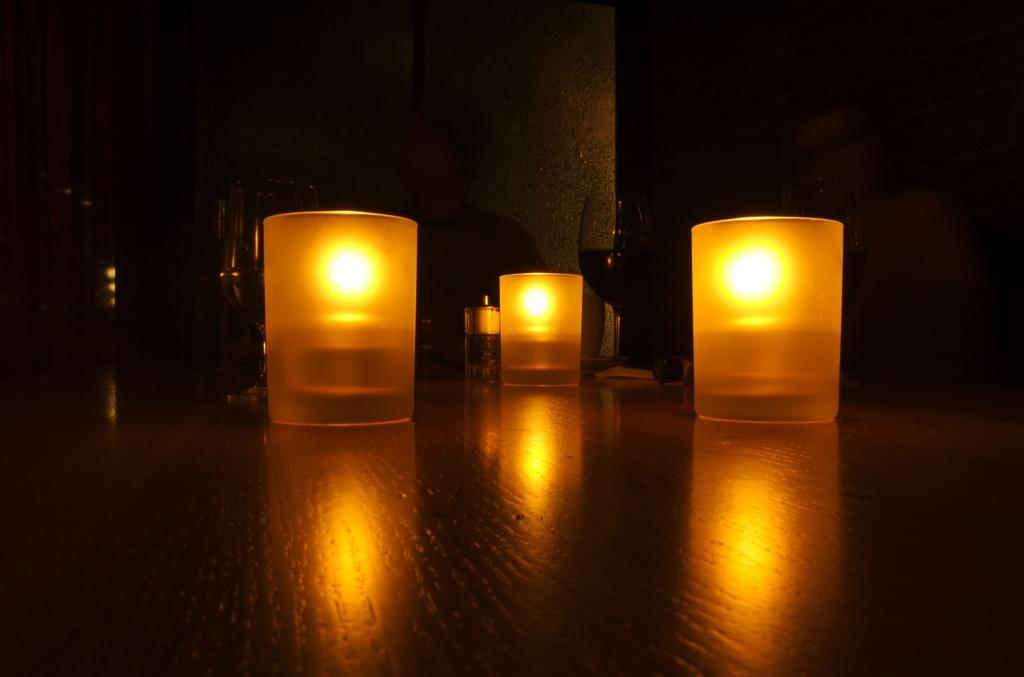What color are the lights in the image? The lights in the image are yellow. What objects are present in the image besides the lights? There are glasses in the image. Is there a chair next to the glasses in the image? There is no mention of a chair in the provided facts, so we cannot determine if there is one present in the image. 